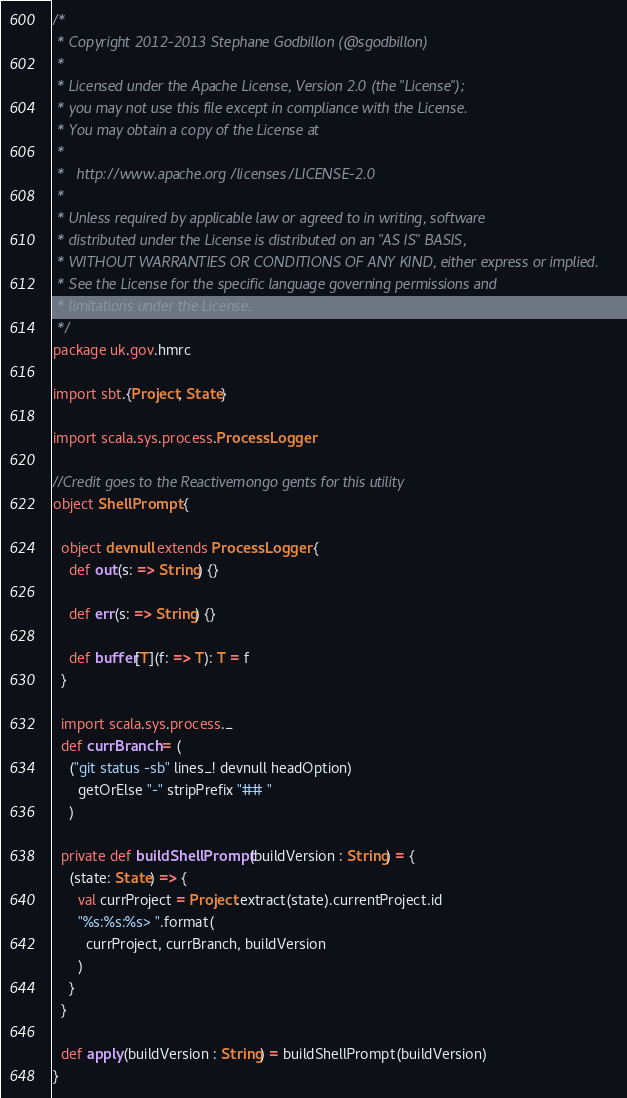Convert code to text. <code><loc_0><loc_0><loc_500><loc_500><_Scala_>/*
 * Copyright 2012-2013 Stephane Godbillon (@sgodbillon)
 *
 * Licensed under the Apache License, Version 2.0 (the "License");
 * you may not use this file except in compliance with the License.
 * You may obtain a copy of the License at
 *
 *   http://www.apache.org/licenses/LICENSE-2.0
 *
 * Unless required by applicable law or agreed to in writing, software
 * distributed under the License is distributed on an "AS IS" BASIS,
 * WITHOUT WARRANTIES OR CONDITIONS OF ANY KIND, either express or implied.
 * See the License for the specific language governing permissions and
 * limitations under the License.
 */
package uk.gov.hmrc

import sbt.{Project, State}

import scala.sys.process.ProcessLogger

//Credit goes to the Reactivemongo gents for this utility
object ShellPrompt {

  object devnull extends ProcessLogger {
    def out(s: => String) {}

    def err(s: => String) {}

    def buffer[T](f: => T): T = f
  }

  import scala.sys.process._
  def currBranch = (
    ("git status -sb" lines_! devnull headOption)
      getOrElse "-" stripPrefix "## "
    )

  private def buildShellPrompt(buildVersion : String) = {
    (state: State) => {
      val currProject = Project.extract(state).currentProject.id
      "%s:%s:%s> ".format(
        currProject, currBranch, buildVersion
      )
    }
  }

  def apply(buildVersion : String) = buildShellPrompt(buildVersion)
}

</code> 